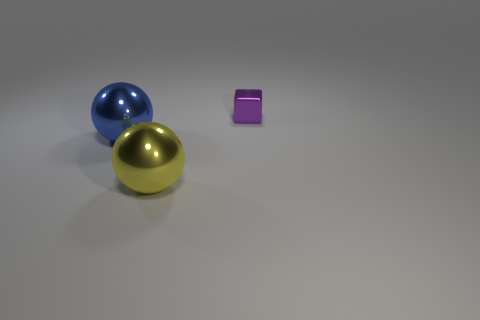Add 2 large blue metallic objects. How many objects exist? 5 Subtract all blocks. How many objects are left? 2 Add 3 small cyan metal balls. How many small cyan metal balls exist? 3 Subtract 0 red cylinders. How many objects are left? 3 Subtract all yellow rubber cylinders. Subtract all small purple metal objects. How many objects are left? 2 Add 2 tiny purple shiny things. How many tiny purple shiny things are left? 3 